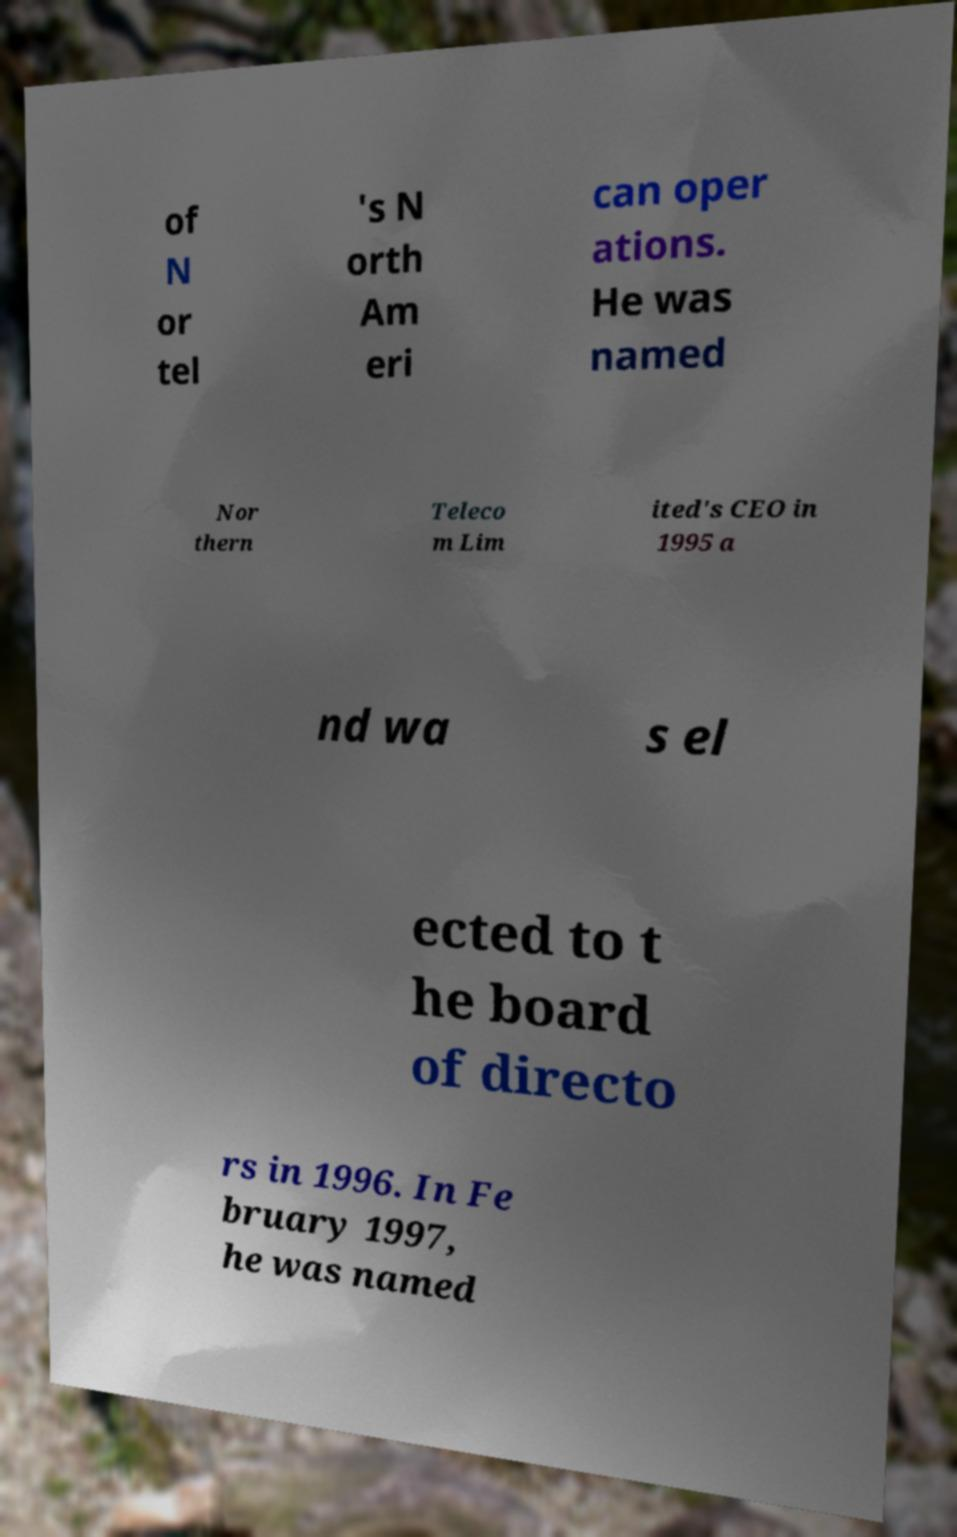Please identify and transcribe the text found in this image. of N or tel 's N orth Am eri can oper ations. He was named Nor thern Teleco m Lim ited's CEO in 1995 a nd wa s el ected to t he board of directo rs in 1996. In Fe bruary 1997, he was named 